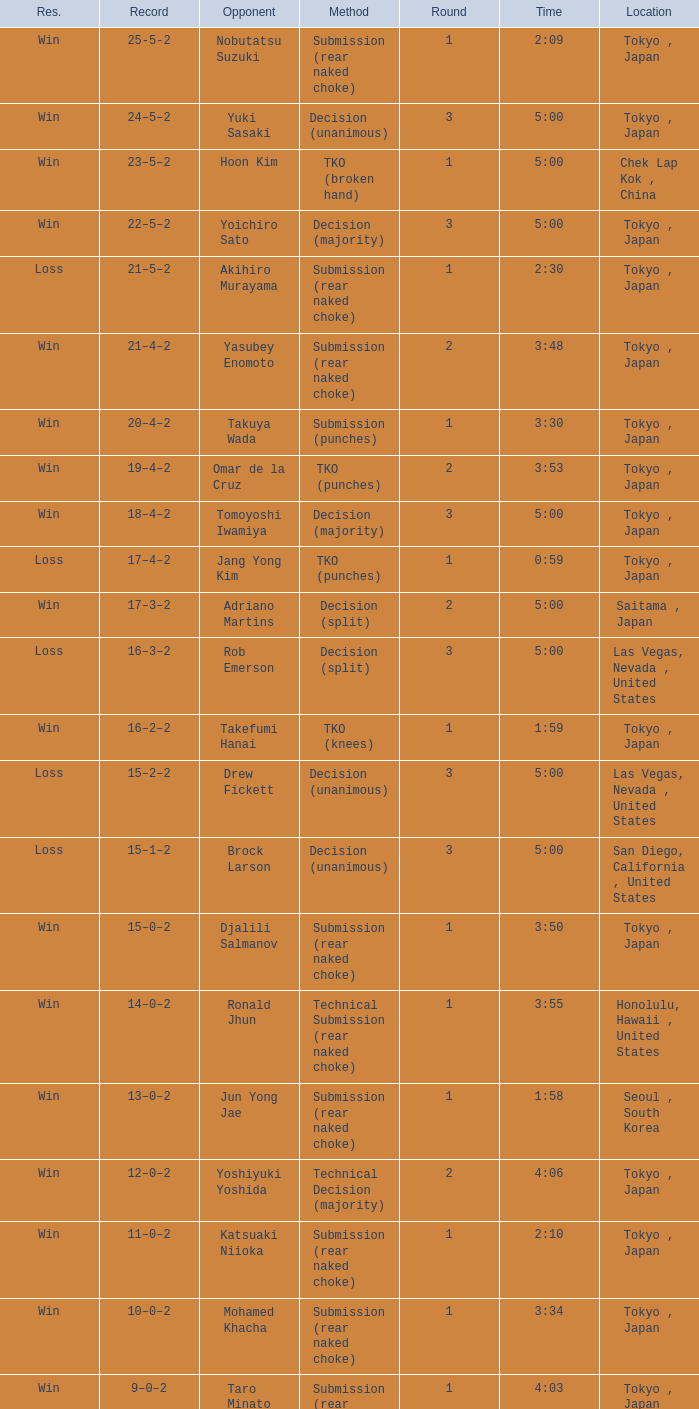What approach featured adriano martins as an adversary and a span of 5:00? Decision (split). 